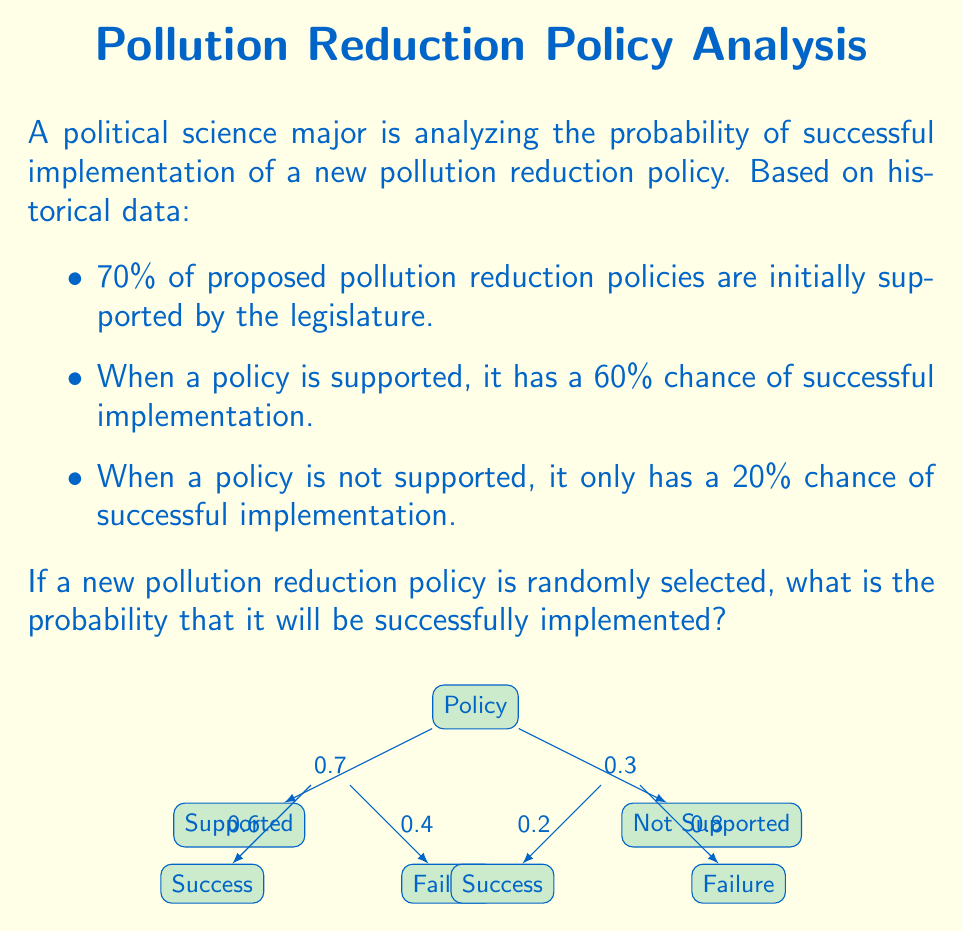What is the answer to this math problem? To solve this problem, we can use the Law of Total Probability. Let's break it down step-by-step:

1) Let A be the event that the policy is successfully implemented, and B be the event that the policy is supported.

2) We're given:
   P(B) = 0.7 (probability of support)
   P(A|B) = 0.6 (probability of success given support)
   P(A|not B) = 0.2 (probability of success given no support)

3) The Law of Total Probability states:
   P(A) = P(A|B) * P(B) + P(A|not B) * P(not B)

4) We know P(B) = 0.7, so P(not B) = 1 - 0.7 = 0.3

5) Now let's plug in the values:
   P(A) = 0.6 * 0.7 + 0.2 * 0.3

6) Calculate:
   P(A) = 0.42 + 0.06 = 0.48

Therefore, the probability that a randomly selected pollution reduction policy will be successfully implemented is 0.48 or 48%.
Answer: 0.48 